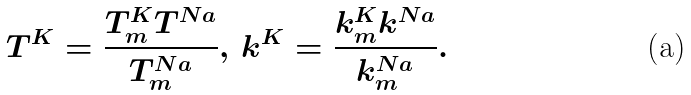<formula> <loc_0><loc_0><loc_500><loc_500>T ^ { K } = \frac { T _ { m } ^ { K } T ^ { N a } } { T _ { m } ^ { N a } } , \, k ^ { K } = \frac { k _ { m } ^ { K } k ^ { N a } } { k _ { m } ^ { N a } } .</formula> 